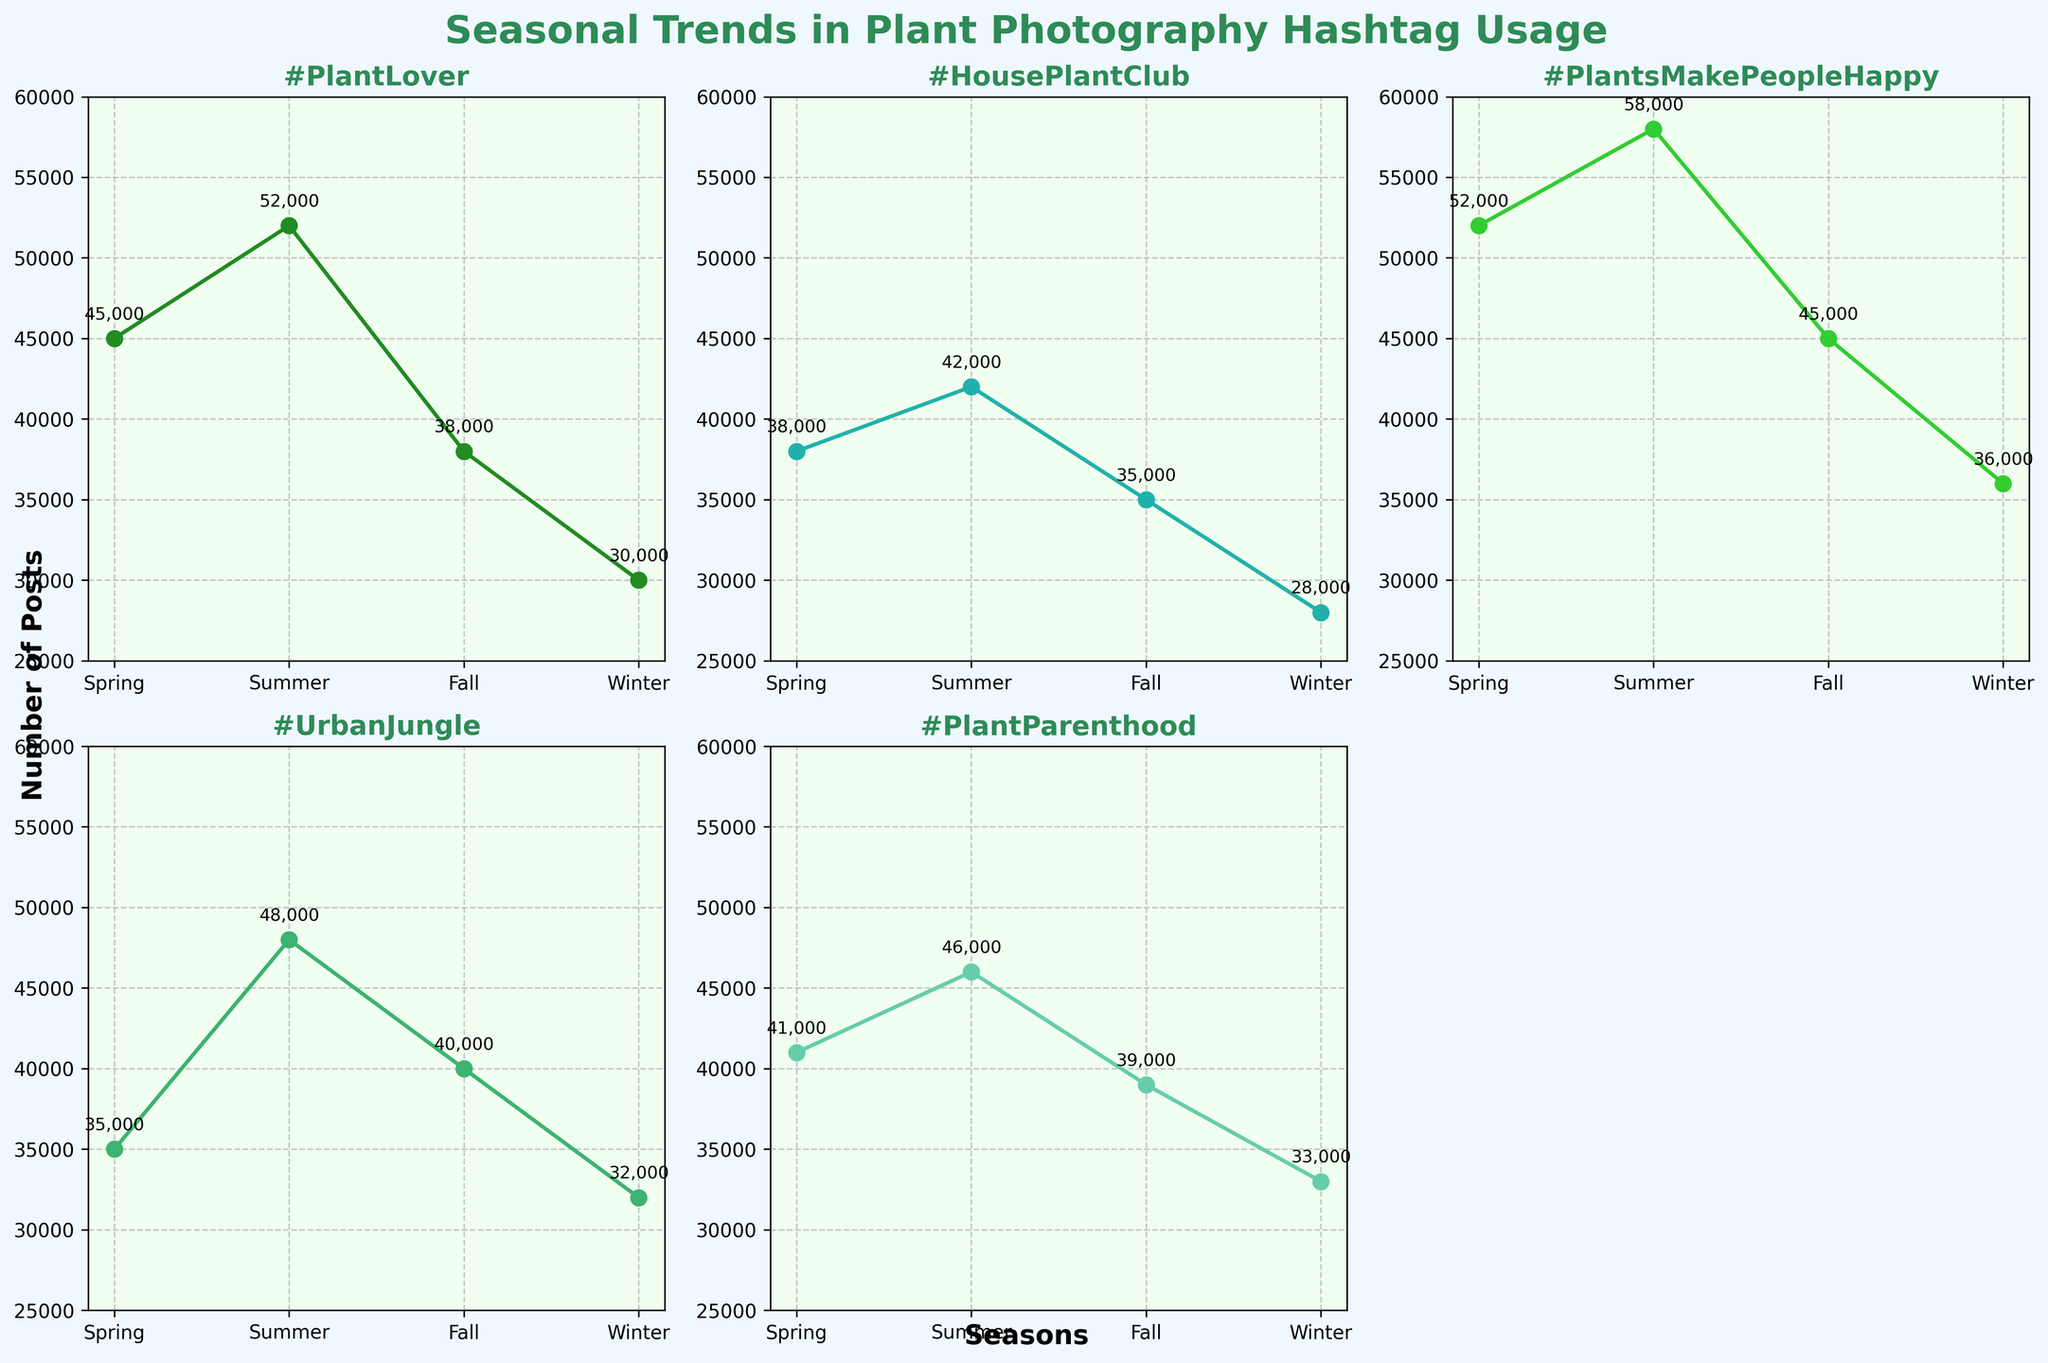What is the title of the figure? The title is usually displayed at the top of the figure. In this case, it reads "Seasonal Trends in Plant Photography Hashtag Usage".
Answer: Seasonal Trends in Plant Photography Hashtag Usage How many subplots are there in the figure? By observing the layout, there are six subplots, but one of them is removed, resulting in five used subplots.
Answer: 5 Which season has the highest number of posts for the hashtag #HousePlantClub? According to the plot for #HousePlantClub, the highest point on the graph occurs during the Summer season with 42,000 posts.
Answer: Summer What is the trend of the hashtag #PlantParenthood across the seasons? The trend for #PlantParenthood shows the highest number of posts in the Summer, followed by Spring, Fall, and the least in Winter.
Answer: Rises in Summer, then declines through Fall and Winter Which hashtag has the most significant drop in usage from Summer to Fall? To determine this, compare the drop in posts from Summer to Fall for each hashtag. The hashtag #PlantsMakePeopleHappy shows a decrease from 58,000 in Summer to 45,000 in Fall, a significant drop.
Answer: #PlantsMakePeopleHappy Which season has the lowest hashtag usage overall? Examine all subplots and note which season appears least across all lines. Winter consistently shows the lowest number of posts among the hashtags.
Answer: Winter What is the difference in the number of posts for #UrbanJungle between Spring and Winter? Subtract the value of posts in Winter (32,000) from that in Spring (35,000): 35,000 - 32,000 = 3,000 posts.
Answer: 3,000 Which hashtag exhibits the most balanced usage across different seasons? By observing the variations across seasons, #UrbanJungle shows a relatively balanced trend without extreme peaks or troughs.
Answer: #UrbanJungle How many hashtags reached at least 40,000 posts in at least one season? Count the hashtags that have at least one data point greater than or equal to 40,000. All five hashtags have at least one season reaching this number.
Answer: 5 In which season does the hashtag #PlantLover peak? In the #PlantLover subplot, the highest point is observed in the Summer season with 52,000 posts.
Answer: Summer 